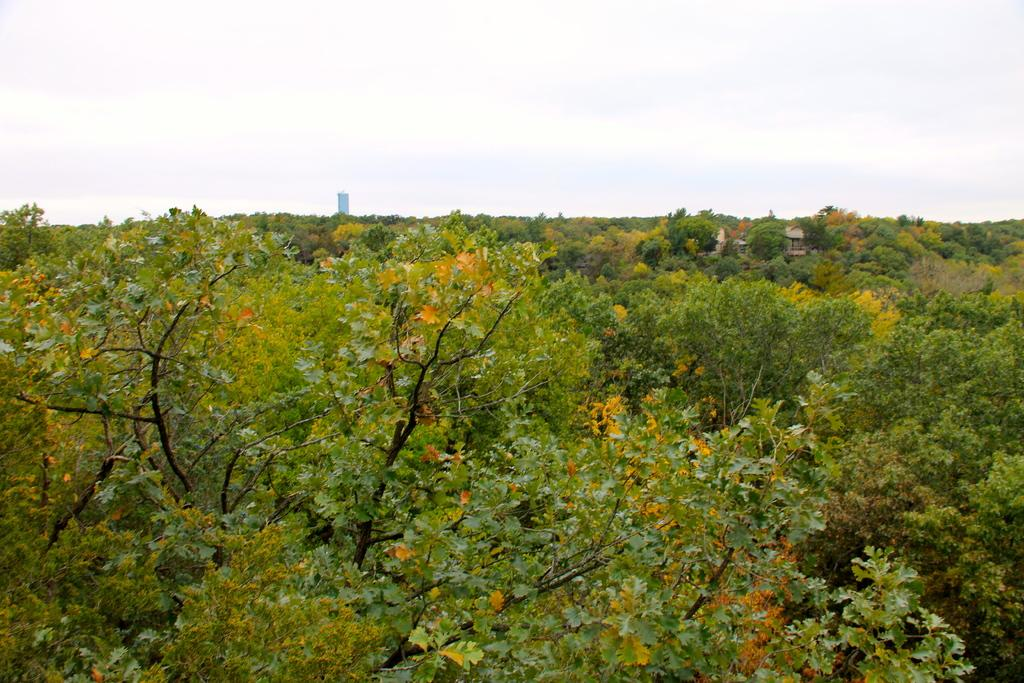What type of vegetation is present in the image? There are trees in the image. What type of structure can be seen in the image? There is a house in the image. What else can be seen in the background of the image? There appears to be a building in the background of the image. What is visible at the top of the image? The sky is visible at the top of the image. Can you tell me how many deer are present in the image? There are no deer present in the image. What type of minister is depicted in the image? There is no minister depicted in the image. 